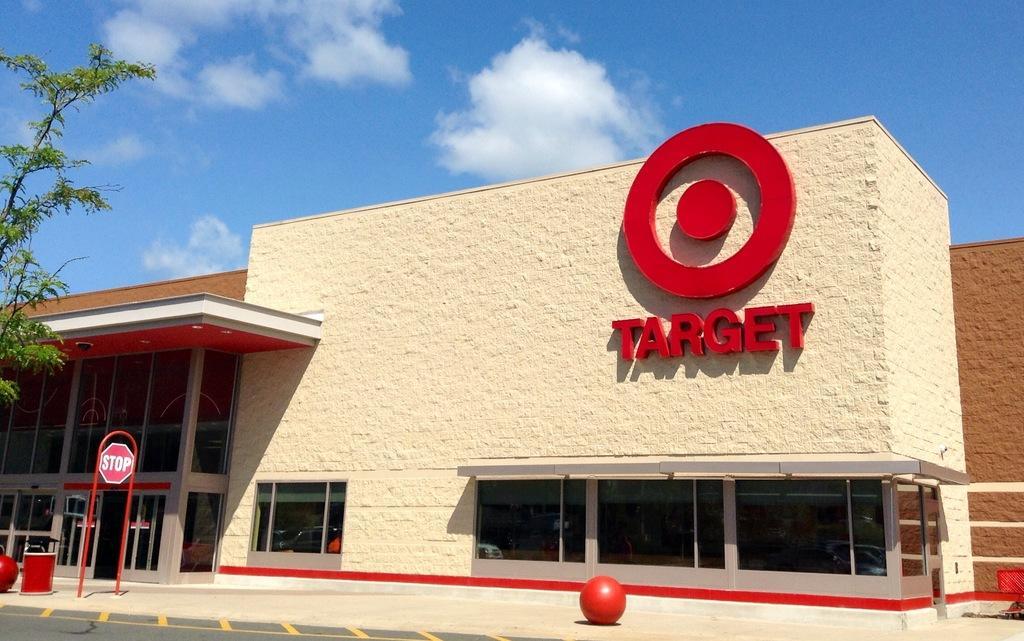Please provide a concise description of this image. In the foreground of this picture, there are red balls, container and a sign board are on the side path. In the background, there is a tree, a building and a logo on it, sky and the cloud. 